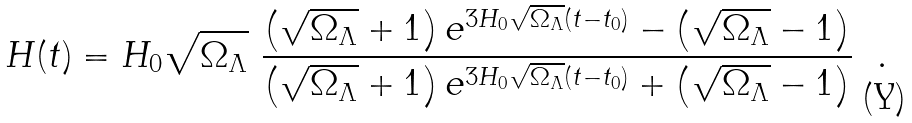<formula> <loc_0><loc_0><loc_500><loc_500>H ( t ) = H _ { 0 } \sqrt { \Omega _ { \Lambda } } \ \frac { \left ( \sqrt { \Omega _ { \Lambda } } + 1 \right ) e ^ { 3 H _ { 0 } \sqrt { \Omega _ { \Lambda } } ( t - t _ { 0 } ) } - \left ( \sqrt { \Omega _ { \Lambda } } - 1 \right ) } { \left ( \sqrt { \Omega _ { \Lambda } } + 1 \right ) e ^ { 3 H _ { 0 } \sqrt { \Omega _ { \Lambda } } ( t - t _ { 0 } ) } + \left ( \sqrt { \Omega _ { \Lambda } } - 1 \right ) } \ \ .</formula> 